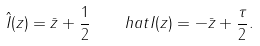Convert formula to latex. <formula><loc_0><loc_0><loc_500><loc_500>\ \hat { I } ( z ) = \bar { z } + \frac { 1 } { 2 } \quad h a t I ( z ) = - \bar { z } + \frac { \tau } { 2 } .</formula> 